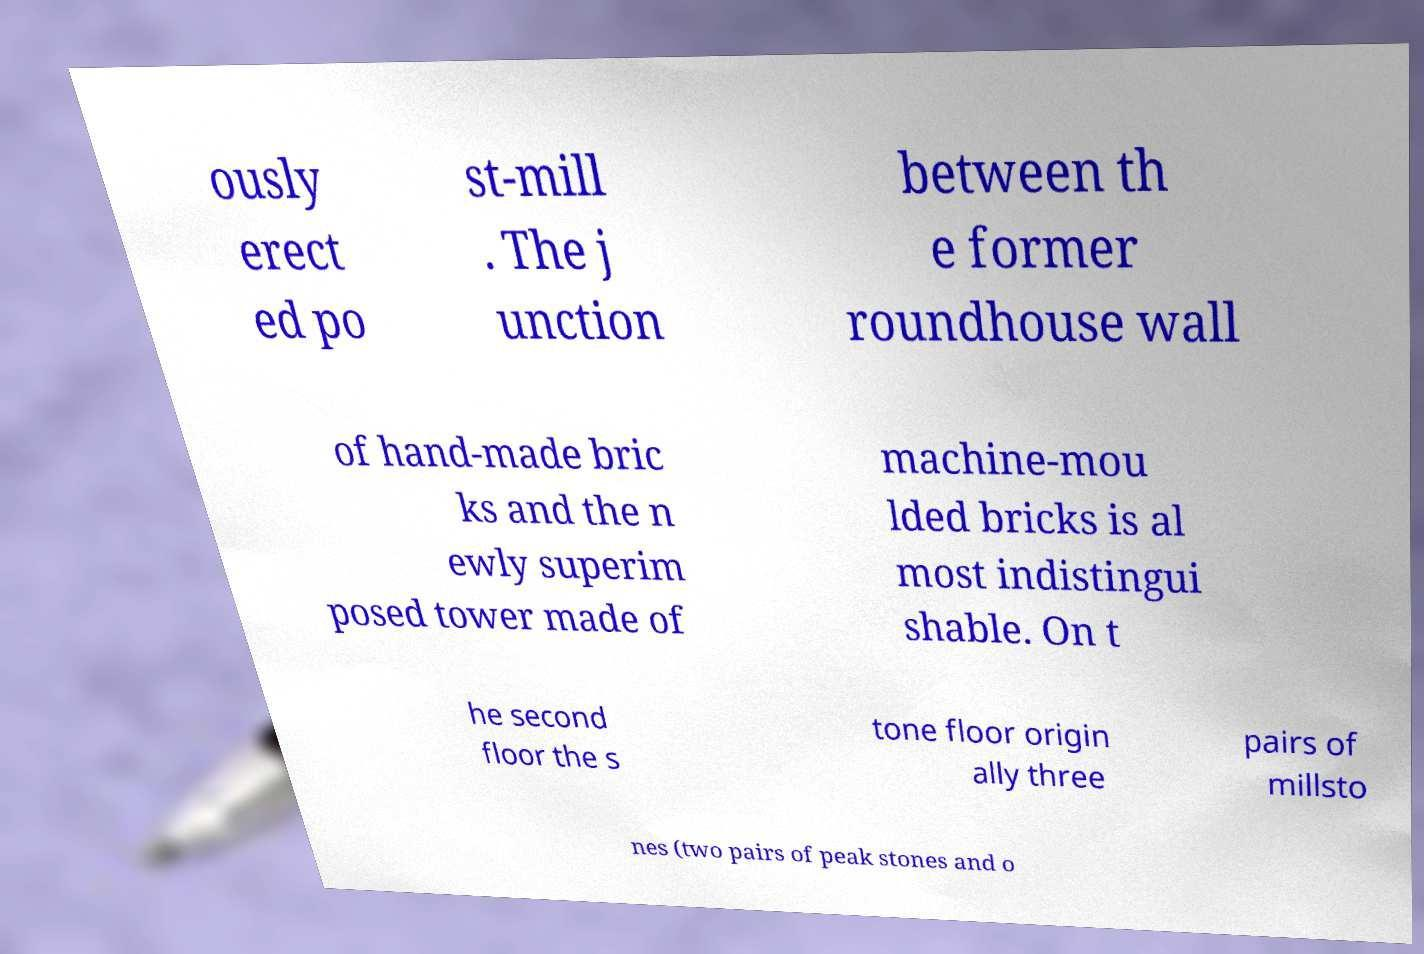Can you read and provide the text displayed in the image?This photo seems to have some interesting text. Can you extract and type it out for me? ously erect ed po st-mill . The j unction between th e former roundhouse wall of hand-made bric ks and the n ewly superim posed tower made of machine-mou lded bricks is al most indistingui shable. On t he second floor the s tone floor origin ally three pairs of millsto nes (two pairs of peak stones and o 